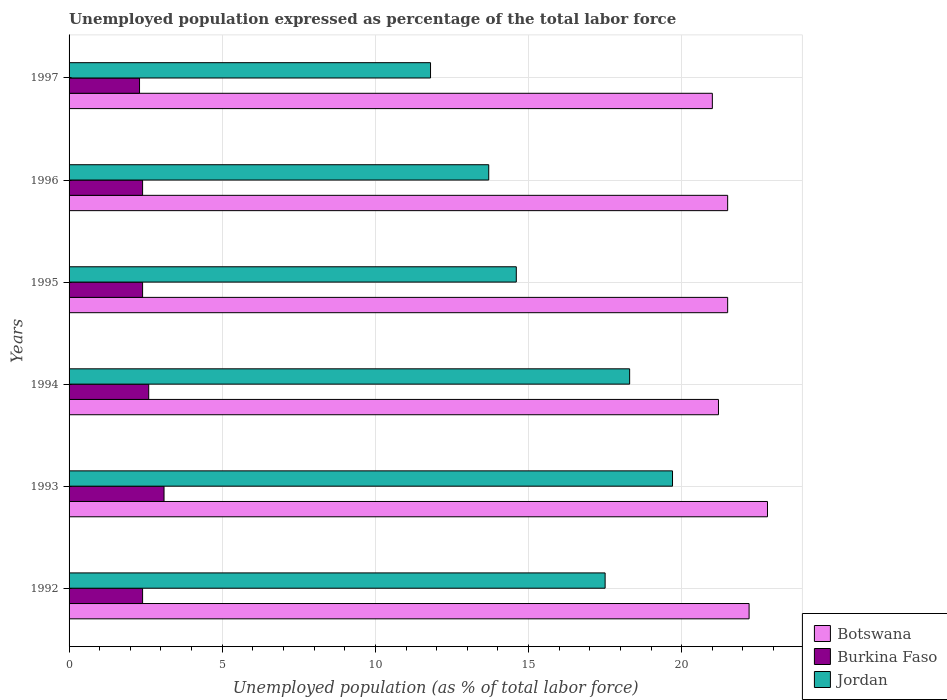Are the number of bars per tick equal to the number of legend labels?
Keep it short and to the point. Yes. What is the label of the 4th group of bars from the top?
Offer a very short reply. 1994. In how many cases, is the number of bars for a given year not equal to the number of legend labels?
Provide a succinct answer. 0. What is the unemployment in in Burkina Faso in 1995?
Keep it short and to the point. 2.4. Across all years, what is the maximum unemployment in in Burkina Faso?
Offer a very short reply. 3.1. Across all years, what is the minimum unemployment in in Botswana?
Make the answer very short. 21. In which year was the unemployment in in Botswana maximum?
Offer a very short reply. 1993. What is the total unemployment in in Botswana in the graph?
Offer a terse response. 130.2. What is the difference between the unemployment in in Jordan in 1993 and that in 1996?
Your response must be concise. 6. What is the difference between the unemployment in in Burkina Faso in 1992 and the unemployment in in Jordan in 1996?
Keep it short and to the point. -11.3. What is the average unemployment in in Burkina Faso per year?
Offer a very short reply. 2.53. In the year 1997, what is the difference between the unemployment in in Botswana and unemployment in in Jordan?
Offer a terse response. 9.2. In how many years, is the unemployment in in Burkina Faso greater than 11 %?
Your response must be concise. 0. What is the ratio of the unemployment in in Jordan in 1996 to that in 1997?
Your answer should be very brief. 1.16. What is the difference between the highest and the second highest unemployment in in Jordan?
Provide a succinct answer. 1.4. What is the difference between the highest and the lowest unemployment in in Botswana?
Provide a succinct answer. 1.8. In how many years, is the unemployment in in Burkina Faso greater than the average unemployment in in Burkina Faso taken over all years?
Offer a very short reply. 2. What does the 3rd bar from the top in 1997 represents?
Your answer should be very brief. Botswana. What does the 2nd bar from the bottom in 1993 represents?
Offer a very short reply. Burkina Faso. Is it the case that in every year, the sum of the unemployment in in Botswana and unemployment in in Burkina Faso is greater than the unemployment in in Jordan?
Your answer should be very brief. Yes. How many bars are there?
Your answer should be very brief. 18. How many years are there in the graph?
Your response must be concise. 6. What is the difference between two consecutive major ticks on the X-axis?
Keep it short and to the point. 5. Are the values on the major ticks of X-axis written in scientific E-notation?
Provide a short and direct response. No. Where does the legend appear in the graph?
Your answer should be very brief. Bottom right. How many legend labels are there?
Provide a short and direct response. 3. How are the legend labels stacked?
Your response must be concise. Vertical. What is the title of the graph?
Make the answer very short. Unemployed population expressed as percentage of the total labor force. What is the label or title of the X-axis?
Give a very brief answer. Unemployed population (as % of total labor force). What is the label or title of the Y-axis?
Your answer should be very brief. Years. What is the Unemployed population (as % of total labor force) in Botswana in 1992?
Make the answer very short. 22.2. What is the Unemployed population (as % of total labor force) in Burkina Faso in 1992?
Your answer should be compact. 2.4. What is the Unemployed population (as % of total labor force) in Jordan in 1992?
Provide a succinct answer. 17.5. What is the Unemployed population (as % of total labor force) in Botswana in 1993?
Ensure brevity in your answer.  22.8. What is the Unemployed population (as % of total labor force) in Burkina Faso in 1993?
Provide a short and direct response. 3.1. What is the Unemployed population (as % of total labor force) of Jordan in 1993?
Provide a short and direct response. 19.7. What is the Unemployed population (as % of total labor force) of Botswana in 1994?
Your response must be concise. 21.2. What is the Unemployed population (as % of total labor force) of Burkina Faso in 1994?
Your answer should be compact. 2.6. What is the Unemployed population (as % of total labor force) in Jordan in 1994?
Keep it short and to the point. 18.3. What is the Unemployed population (as % of total labor force) of Burkina Faso in 1995?
Your answer should be compact. 2.4. What is the Unemployed population (as % of total labor force) in Jordan in 1995?
Ensure brevity in your answer.  14.6. What is the Unemployed population (as % of total labor force) of Botswana in 1996?
Offer a very short reply. 21.5. What is the Unemployed population (as % of total labor force) in Burkina Faso in 1996?
Ensure brevity in your answer.  2.4. What is the Unemployed population (as % of total labor force) in Jordan in 1996?
Keep it short and to the point. 13.7. What is the Unemployed population (as % of total labor force) of Botswana in 1997?
Ensure brevity in your answer.  21. What is the Unemployed population (as % of total labor force) of Burkina Faso in 1997?
Your response must be concise. 2.3. What is the Unemployed population (as % of total labor force) in Jordan in 1997?
Your answer should be very brief. 11.8. Across all years, what is the maximum Unemployed population (as % of total labor force) of Botswana?
Keep it short and to the point. 22.8. Across all years, what is the maximum Unemployed population (as % of total labor force) of Burkina Faso?
Ensure brevity in your answer.  3.1. Across all years, what is the maximum Unemployed population (as % of total labor force) of Jordan?
Your response must be concise. 19.7. Across all years, what is the minimum Unemployed population (as % of total labor force) in Burkina Faso?
Ensure brevity in your answer.  2.3. Across all years, what is the minimum Unemployed population (as % of total labor force) of Jordan?
Provide a succinct answer. 11.8. What is the total Unemployed population (as % of total labor force) in Botswana in the graph?
Your response must be concise. 130.2. What is the total Unemployed population (as % of total labor force) in Jordan in the graph?
Provide a short and direct response. 95.6. What is the difference between the Unemployed population (as % of total labor force) in Botswana in 1992 and that in 1993?
Your answer should be very brief. -0.6. What is the difference between the Unemployed population (as % of total labor force) in Jordan in 1992 and that in 1993?
Offer a terse response. -2.2. What is the difference between the Unemployed population (as % of total labor force) in Burkina Faso in 1992 and that in 1994?
Your answer should be compact. -0.2. What is the difference between the Unemployed population (as % of total labor force) of Jordan in 1992 and that in 1994?
Your answer should be very brief. -0.8. What is the difference between the Unemployed population (as % of total labor force) in Burkina Faso in 1992 and that in 1995?
Provide a succinct answer. 0. What is the difference between the Unemployed population (as % of total labor force) in Burkina Faso in 1992 and that in 1996?
Your response must be concise. 0. What is the difference between the Unemployed population (as % of total labor force) in Botswana in 1992 and that in 1997?
Ensure brevity in your answer.  1.2. What is the difference between the Unemployed population (as % of total labor force) in Burkina Faso in 1992 and that in 1997?
Ensure brevity in your answer.  0.1. What is the difference between the Unemployed population (as % of total labor force) in Jordan in 1993 and that in 1994?
Provide a succinct answer. 1.4. What is the difference between the Unemployed population (as % of total labor force) of Jordan in 1993 and that in 1995?
Provide a succinct answer. 5.1. What is the difference between the Unemployed population (as % of total labor force) of Botswana in 1993 and that in 1996?
Your answer should be compact. 1.3. What is the difference between the Unemployed population (as % of total labor force) of Burkina Faso in 1993 and that in 1996?
Offer a very short reply. 0.7. What is the difference between the Unemployed population (as % of total labor force) in Burkina Faso in 1993 and that in 1997?
Ensure brevity in your answer.  0.8. What is the difference between the Unemployed population (as % of total labor force) in Burkina Faso in 1994 and that in 1995?
Provide a short and direct response. 0.2. What is the difference between the Unemployed population (as % of total labor force) in Botswana in 1994 and that in 1997?
Offer a terse response. 0.2. What is the difference between the Unemployed population (as % of total labor force) in Burkina Faso in 1994 and that in 1997?
Your response must be concise. 0.3. What is the difference between the Unemployed population (as % of total labor force) in Botswana in 1995 and that in 1996?
Your answer should be compact. 0. What is the difference between the Unemployed population (as % of total labor force) in Botswana in 1995 and that in 1997?
Your response must be concise. 0.5. What is the difference between the Unemployed population (as % of total labor force) in Botswana in 1996 and that in 1997?
Provide a short and direct response. 0.5. What is the difference between the Unemployed population (as % of total labor force) of Burkina Faso in 1996 and that in 1997?
Provide a succinct answer. 0.1. What is the difference between the Unemployed population (as % of total labor force) in Botswana in 1992 and the Unemployed population (as % of total labor force) in Jordan in 1993?
Your answer should be compact. 2.5. What is the difference between the Unemployed population (as % of total labor force) in Burkina Faso in 1992 and the Unemployed population (as % of total labor force) in Jordan in 1993?
Make the answer very short. -17.3. What is the difference between the Unemployed population (as % of total labor force) of Botswana in 1992 and the Unemployed population (as % of total labor force) of Burkina Faso in 1994?
Your answer should be compact. 19.6. What is the difference between the Unemployed population (as % of total labor force) of Botswana in 1992 and the Unemployed population (as % of total labor force) of Jordan in 1994?
Provide a short and direct response. 3.9. What is the difference between the Unemployed population (as % of total labor force) of Burkina Faso in 1992 and the Unemployed population (as % of total labor force) of Jordan in 1994?
Give a very brief answer. -15.9. What is the difference between the Unemployed population (as % of total labor force) of Botswana in 1992 and the Unemployed population (as % of total labor force) of Burkina Faso in 1995?
Your response must be concise. 19.8. What is the difference between the Unemployed population (as % of total labor force) of Botswana in 1992 and the Unemployed population (as % of total labor force) of Burkina Faso in 1996?
Make the answer very short. 19.8. What is the difference between the Unemployed population (as % of total labor force) in Burkina Faso in 1992 and the Unemployed population (as % of total labor force) in Jordan in 1996?
Offer a very short reply. -11.3. What is the difference between the Unemployed population (as % of total labor force) in Botswana in 1992 and the Unemployed population (as % of total labor force) in Jordan in 1997?
Your answer should be compact. 10.4. What is the difference between the Unemployed population (as % of total labor force) of Burkina Faso in 1992 and the Unemployed population (as % of total labor force) of Jordan in 1997?
Offer a very short reply. -9.4. What is the difference between the Unemployed population (as % of total labor force) of Botswana in 1993 and the Unemployed population (as % of total labor force) of Burkina Faso in 1994?
Provide a short and direct response. 20.2. What is the difference between the Unemployed population (as % of total labor force) in Botswana in 1993 and the Unemployed population (as % of total labor force) in Jordan in 1994?
Your response must be concise. 4.5. What is the difference between the Unemployed population (as % of total labor force) of Burkina Faso in 1993 and the Unemployed population (as % of total labor force) of Jordan in 1994?
Give a very brief answer. -15.2. What is the difference between the Unemployed population (as % of total labor force) in Botswana in 1993 and the Unemployed population (as % of total labor force) in Burkina Faso in 1995?
Provide a succinct answer. 20.4. What is the difference between the Unemployed population (as % of total labor force) in Botswana in 1993 and the Unemployed population (as % of total labor force) in Jordan in 1995?
Your answer should be very brief. 8.2. What is the difference between the Unemployed population (as % of total labor force) in Botswana in 1993 and the Unemployed population (as % of total labor force) in Burkina Faso in 1996?
Provide a succinct answer. 20.4. What is the difference between the Unemployed population (as % of total labor force) of Botswana in 1994 and the Unemployed population (as % of total labor force) of Jordan in 1995?
Make the answer very short. 6.6. What is the difference between the Unemployed population (as % of total labor force) in Botswana in 1994 and the Unemployed population (as % of total labor force) in Burkina Faso in 1996?
Your response must be concise. 18.8. What is the difference between the Unemployed population (as % of total labor force) in Botswana in 1994 and the Unemployed population (as % of total labor force) in Jordan in 1996?
Offer a very short reply. 7.5. What is the difference between the Unemployed population (as % of total labor force) of Burkina Faso in 1994 and the Unemployed population (as % of total labor force) of Jordan in 1996?
Offer a very short reply. -11.1. What is the difference between the Unemployed population (as % of total labor force) of Botswana in 1994 and the Unemployed population (as % of total labor force) of Jordan in 1997?
Offer a terse response. 9.4. What is the difference between the Unemployed population (as % of total labor force) in Burkina Faso in 1995 and the Unemployed population (as % of total labor force) in Jordan in 1996?
Offer a terse response. -11.3. What is the difference between the Unemployed population (as % of total labor force) of Botswana in 1995 and the Unemployed population (as % of total labor force) of Burkina Faso in 1997?
Ensure brevity in your answer.  19.2. What is the difference between the Unemployed population (as % of total labor force) of Botswana in 1996 and the Unemployed population (as % of total labor force) of Burkina Faso in 1997?
Offer a very short reply. 19.2. What is the difference between the Unemployed population (as % of total labor force) of Botswana in 1996 and the Unemployed population (as % of total labor force) of Jordan in 1997?
Keep it short and to the point. 9.7. What is the average Unemployed population (as % of total labor force) in Botswana per year?
Make the answer very short. 21.7. What is the average Unemployed population (as % of total labor force) in Burkina Faso per year?
Provide a succinct answer. 2.53. What is the average Unemployed population (as % of total labor force) in Jordan per year?
Your answer should be very brief. 15.93. In the year 1992, what is the difference between the Unemployed population (as % of total labor force) of Botswana and Unemployed population (as % of total labor force) of Burkina Faso?
Your answer should be compact. 19.8. In the year 1992, what is the difference between the Unemployed population (as % of total labor force) in Botswana and Unemployed population (as % of total labor force) in Jordan?
Keep it short and to the point. 4.7. In the year 1992, what is the difference between the Unemployed population (as % of total labor force) of Burkina Faso and Unemployed population (as % of total labor force) of Jordan?
Your response must be concise. -15.1. In the year 1993, what is the difference between the Unemployed population (as % of total labor force) in Botswana and Unemployed population (as % of total labor force) in Jordan?
Ensure brevity in your answer.  3.1. In the year 1993, what is the difference between the Unemployed population (as % of total labor force) in Burkina Faso and Unemployed population (as % of total labor force) in Jordan?
Offer a very short reply. -16.6. In the year 1994, what is the difference between the Unemployed population (as % of total labor force) in Botswana and Unemployed population (as % of total labor force) in Burkina Faso?
Make the answer very short. 18.6. In the year 1994, what is the difference between the Unemployed population (as % of total labor force) in Botswana and Unemployed population (as % of total labor force) in Jordan?
Make the answer very short. 2.9. In the year 1994, what is the difference between the Unemployed population (as % of total labor force) of Burkina Faso and Unemployed population (as % of total labor force) of Jordan?
Provide a short and direct response. -15.7. In the year 1995, what is the difference between the Unemployed population (as % of total labor force) of Botswana and Unemployed population (as % of total labor force) of Burkina Faso?
Offer a terse response. 19.1. In the year 1995, what is the difference between the Unemployed population (as % of total labor force) in Botswana and Unemployed population (as % of total labor force) in Jordan?
Give a very brief answer. 6.9. In the year 1995, what is the difference between the Unemployed population (as % of total labor force) in Burkina Faso and Unemployed population (as % of total labor force) in Jordan?
Ensure brevity in your answer.  -12.2. In the year 1996, what is the difference between the Unemployed population (as % of total labor force) in Botswana and Unemployed population (as % of total labor force) in Burkina Faso?
Your response must be concise. 19.1. In the year 1996, what is the difference between the Unemployed population (as % of total labor force) of Burkina Faso and Unemployed population (as % of total labor force) of Jordan?
Your answer should be compact. -11.3. In the year 1997, what is the difference between the Unemployed population (as % of total labor force) in Botswana and Unemployed population (as % of total labor force) in Burkina Faso?
Your response must be concise. 18.7. In the year 1997, what is the difference between the Unemployed population (as % of total labor force) of Botswana and Unemployed population (as % of total labor force) of Jordan?
Provide a short and direct response. 9.2. In the year 1997, what is the difference between the Unemployed population (as % of total labor force) of Burkina Faso and Unemployed population (as % of total labor force) of Jordan?
Your response must be concise. -9.5. What is the ratio of the Unemployed population (as % of total labor force) of Botswana in 1992 to that in 1993?
Make the answer very short. 0.97. What is the ratio of the Unemployed population (as % of total labor force) in Burkina Faso in 1992 to that in 1993?
Your answer should be very brief. 0.77. What is the ratio of the Unemployed population (as % of total labor force) in Jordan in 1992 to that in 1993?
Offer a very short reply. 0.89. What is the ratio of the Unemployed population (as % of total labor force) in Botswana in 1992 to that in 1994?
Your response must be concise. 1.05. What is the ratio of the Unemployed population (as % of total labor force) in Jordan in 1992 to that in 1994?
Ensure brevity in your answer.  0.96. What is the ratio of the Unemployed population (as % of total labor force) of Botswana in 1992 to that in 1995?
Provide a succinct answer. 1.03. What is the ratio of the Unemployed population (as % of total labor force) in Jordan in 1992 to that in 1995?
Offer a terse response. 1.2. What is the ratio of the Unemployed population (as % of total labor force) of Botswana in 1992 to that in 1996?
Your response must be concise. 1.03. What is the ratio of the Unemployed population (as % of total labor force) of Jordan in 1992 to that in 1996?
Keep it short and to the point. 1.28. What is the ratio of the Unemployed population (as % of total labor force) in Botswana in 1992 to that in 1997?
Provide a short and direct response. 1.06. What is the ratio of the Unemployed population (as % of total labor force) in Burkina Faso in 1992 to that in 1997?
Make the answer very short. 1.04. What is the ratio of the Unemployed population (as % of total labor force) of Jordan in 1992 to that in 1997?
Your answer should be compact. 1.48. What is the ratio of the Unemployed population (as % of total labor force) in Botswana in 1993 to that in 1994?
Your response must be concise. 1.08. What is the ratio of the Unemployed population (as % of total labor force) of Burkina Faso in 1993 to that in 1994?
Make the answer very short. 1.19. What is the ratio of the Unemployed population (as % of total labor force) in Jordan in 1993 to that in 1994?
Provide a succinct answer. 1.08. What is the ratio of the Unemployed population (as % of total labor force) in Botswana in 1993 to that in 1995?
Your response must be concise. 1.06. What is the ratio of the Unemployed population (as % of total labor force) in Burkina Faso in 1993 to that in 1995?
Your response must be concise. 1.29. What is the ratio of the Unemployed population (as % of total labor force) of Jordan in 1993 to that in 1995?
Ensure brevity in your answer.  1.35. What is the ratio of the Unemployed population (as % of total labor force) of Botswana in 1993 to that in 1996?
Make the answer very short. 1.06. What is the ratio of the Unemployed population (as % of total labor force) of Burkina Faso in 1993 to that in 1996?
Provide a short and direct response. 1.29. What is the ratio of the Unemployed population (as % of total labor force) in Jordan in 1993 to that in 1996?
Provide a succinct answer. 1.44. What is the ratio of the Unemployed population (as % of total labor force) in Botswana in 1993 to that in 1997?
Provide a succinct answer. 1.09. What is the ratio of the Unemployed population (as % of total labor force) in Burkina Faso in 1993 to that in 1997?
Offer a terse response. 1.35. What is the ratio of the Unemployed population (as % of total labor force) in Jordan in 1993 to that in 1997?
Your answer should be very brief. 1.67. What is the ratio of the Unemployed population (as % of total labor force) in Botswana in 1994 to that in 1995?
Give a very brief answer. 0.99. What is the ratio of the Unemployed population (as % of total labor force) in Jordan in 1994 to that in 1995?
Your response must be concise. 1.25. What is the ratio of the Unemployed population (as % of total labor force) of Jordan in 1994 to that in 1996?
Offer a terse response. 1.34. What is the ratio of the Unemployed population (as % of total labor force) in Botswana in 1994 to that in 1997?
Provide a short and direct response. 1.01. What is the ratio of the Unemployed population (as % of total labor force) of Burkina Faso in 1994 to that in 1997?
Your answer should be compact. 1.13. What is the ratio of the Unemployed population (as % of total labor force) in Jordan in 1994 to that in 1997?
Your response must be concise. 1.55. What is the ratio of the Unemployed population (as % of total labor force) in Jordan in 1995 to that in 1996?
Your response must be concise. 1.07. What is the ratio of the Unemployed population (as % of total labor force) in Botswana in 1995 to that in 1997?
Make the answer very short. 1.02. What is the ratio of the Unemployed population (as % of total labor force) of Burkina Faso in 1995 to that in 1997?
Your response must be concise. 1.04. What is the ratio of the Unemployed population (as % of total labor force) of Jordan in 1995 to that in 1997?
Make the answer very short. 1.24. What is the ratio of the Unemployed population (as % of total labor force) in Botswana in 1996 to that in 1997?
Ensure brevity in your answer.  1.02. What is the ratio of the Unemployed population (as % of total labor force) in Burkina Faso in 1996 to that in 1997?
Offer a very short reply. 1.04. What is the ratio of the Unemployed population (as % of total labor force) of Jordan in 1996 to that in 1997?
Make the answer very short. 1.16. What is the difference between the highest and the lowest Unemployed population (as % of total labor force) in Botswana?
Provide a succinct answer. 1.8. What is the difference between the highest and the lowest Unemployed population (as % of total labor force) in Jordan?
Your response must be concise. 7.9. 